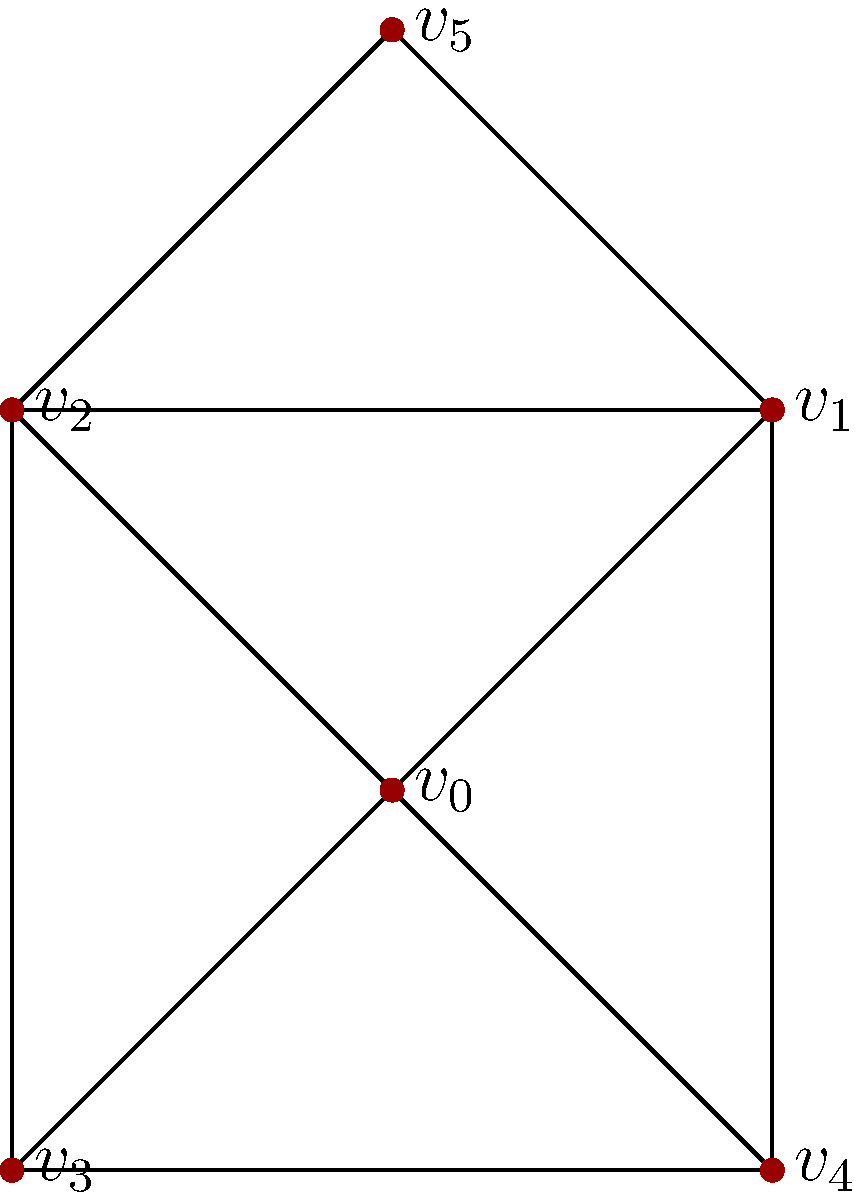In this social network of film critics from diverse backgrounds, which critic (represented by a vertex) has the highest degree centrality, and what is their degree? To determine the critic with the highest degree centrality, we need to count the number of connections (edges) for each vertex in the graph. Let's analyze each vertex:

1. $v_0$: Connected to $v_1$, $v_2$, $v_3$, and $v_4$. Degree = 4.
2. $v_1$: Connected to $v_0$, $v_2$, $v_4$, and $v_5$. Degree = 4.
3. $v_2$: Connected to $v_0$, $v_1$, $v_3$, and $v_5$. Degree = 4.
4. $v_3$: Connected to $v_0$, $v_2$, and $v_4$. Degree = 3.
5. $v_4$: Connected to $v_0$, $v_1$, and $v_3$. Degree = 3.
6. $v_5$: Connected to $v_1$ and $v_2$. Degree = 2.

The highest degree centrality is 4, shared by vertices $v_0$, $v_1$, and $v_2$.

In the context of film critics, this means that critics represented by $v_0$, $v_1$, and $v_2$ have the most connections or collaborations within this diverse network.
Answer: $v_0$, $v_1$, and $v_2$ (degree 4) 